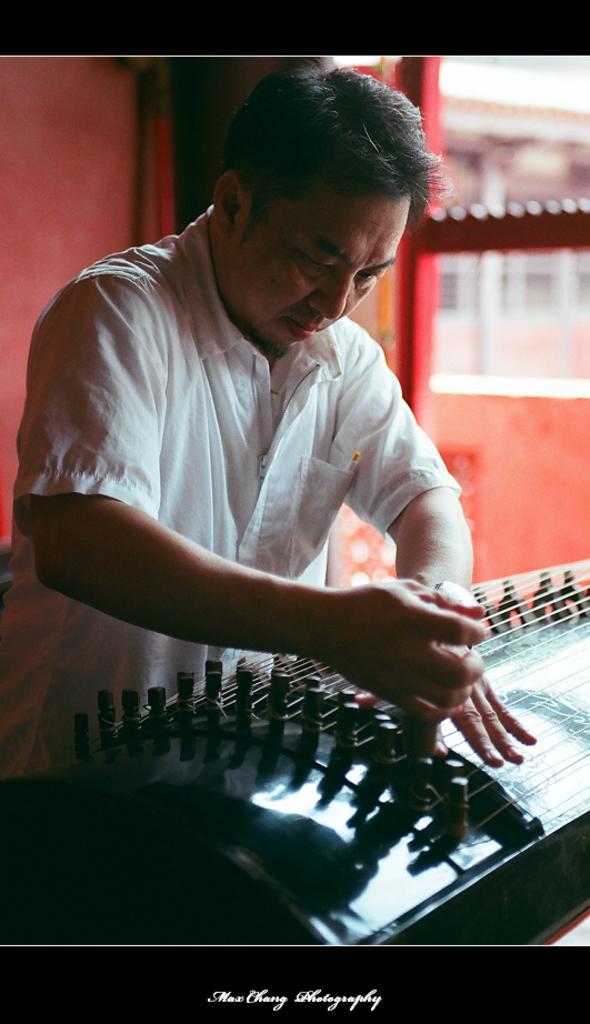Can you describe this image briefly? In the image we can see a man wearing clothes. Here we can see the musical instrument and the background is slightly blurred. 